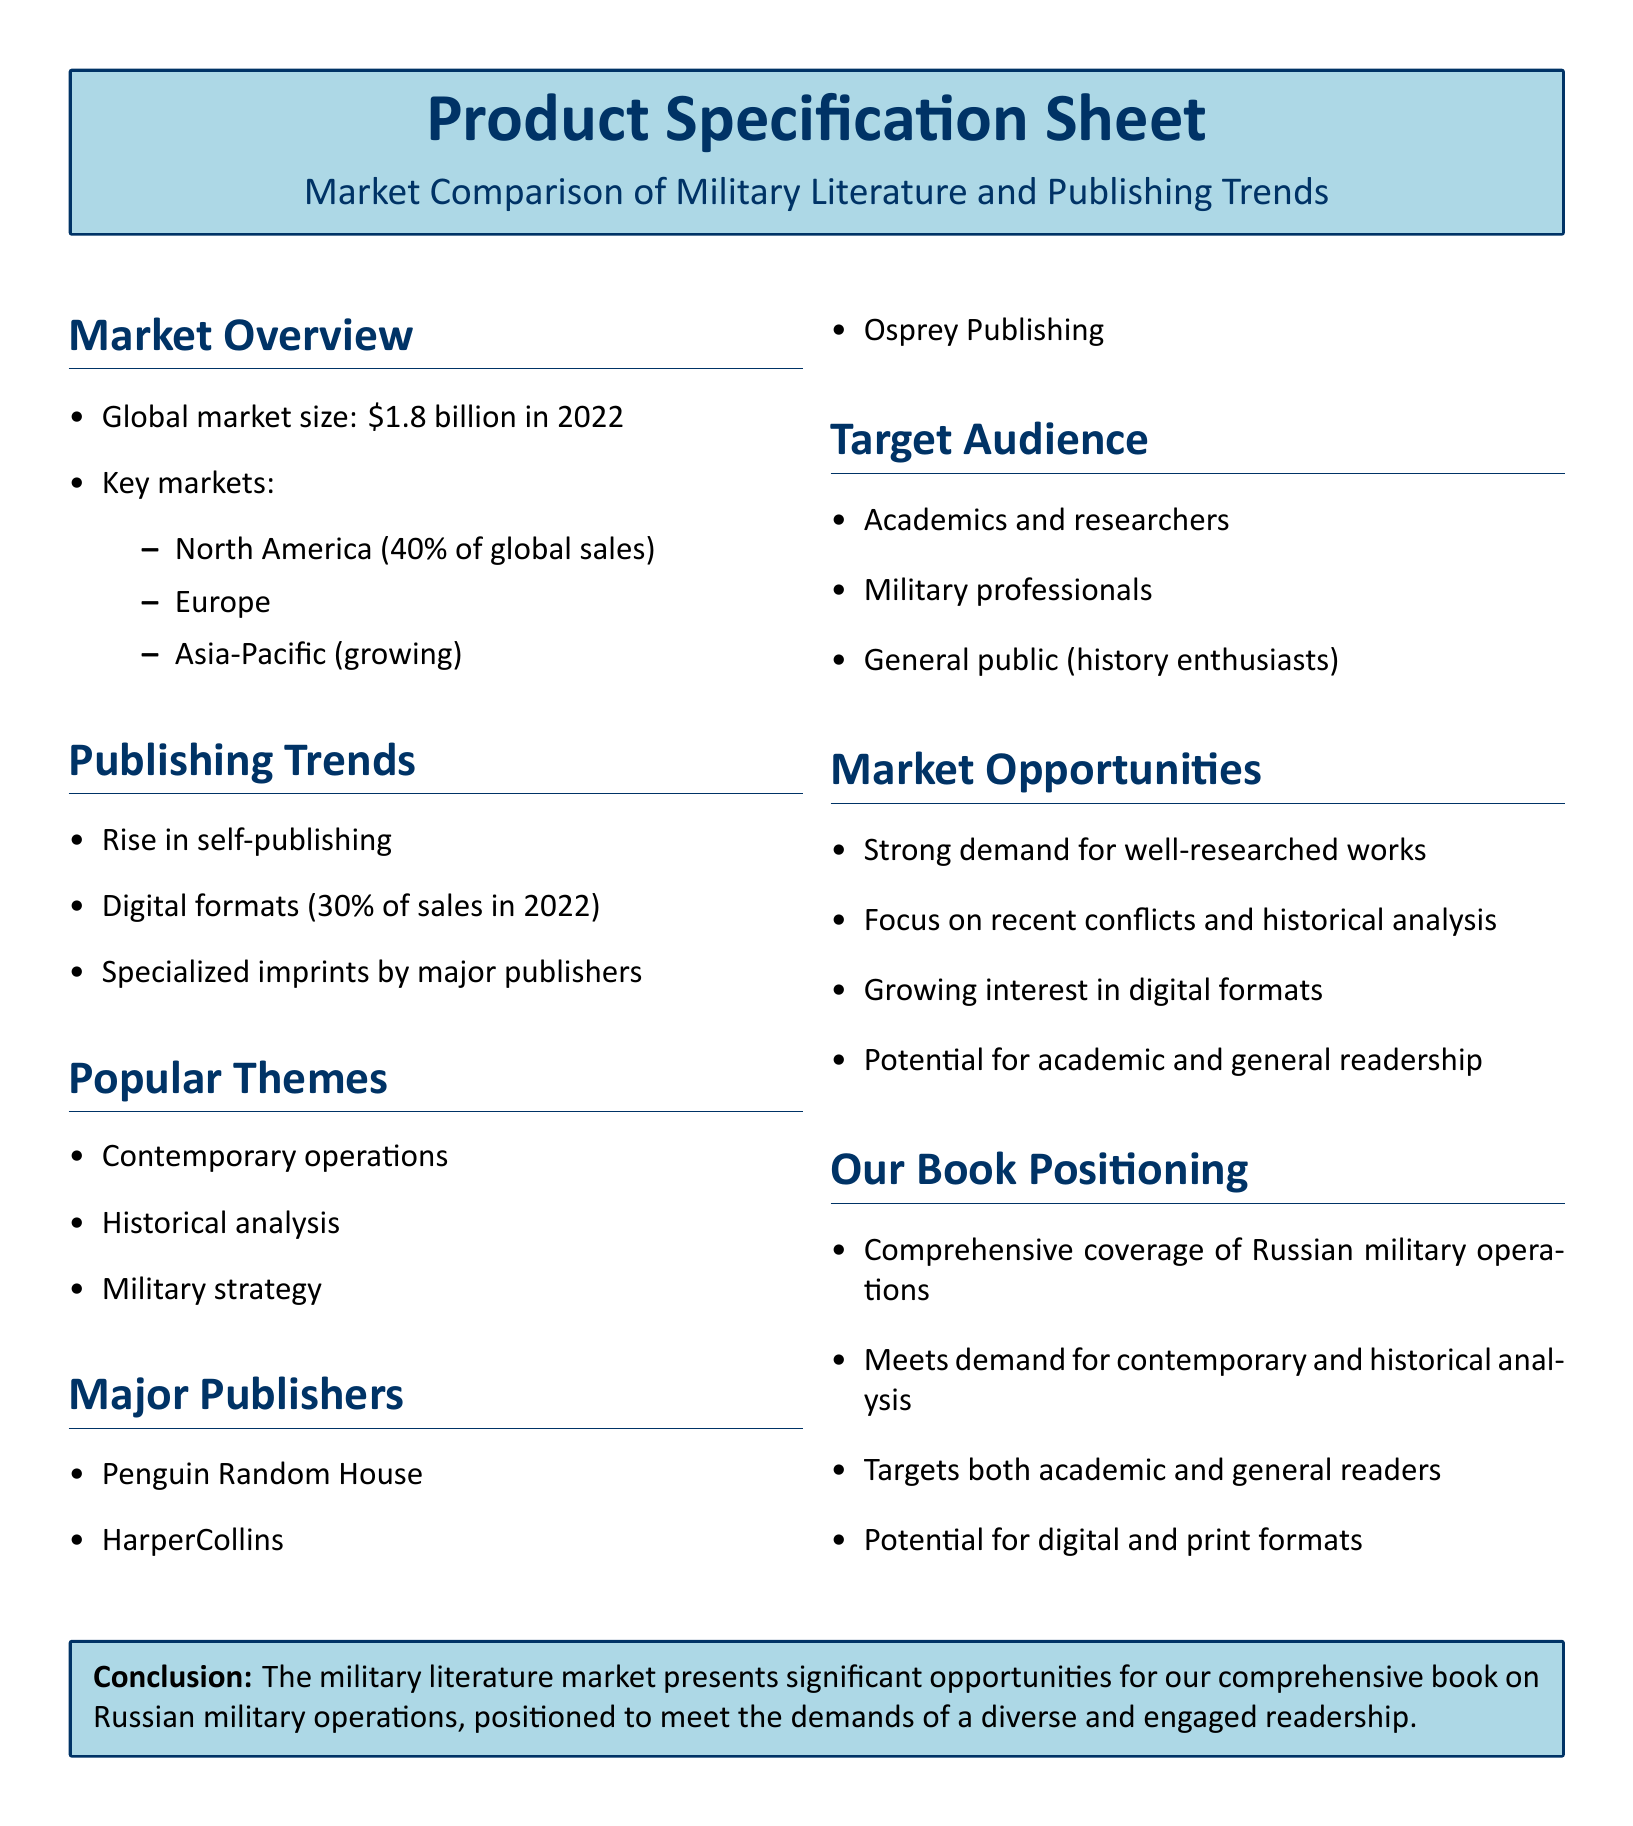What is the global market size for military literature in 2022? The document provides a specific figure, which is $1.8 billion in 2022.
Answer: $1.8 billion Which region accounts for 40% of global sales? The document specifies that North America accounts for this percentage of global sales.
Answer: North America What percentage of sales were digital formats in 2022? This information shows the trend towards digital publishing, with 30% of sales being digital formats.
Answer: 30% Name a major publisher mentioned in the document. The document lists several publishers, one of which is Penguin Random House.
Answer: Penguin Random House What is a popular theme in military literature? The document outlines several themes, including contemporary operations.
Answer: Contemporary operations What type of readers is our book targeting? The document outlines several target audiences, including academics and researchers.
Answer: Academics and researchers What is a key market opportunity identified in the document? The document points out a strong demand for well-researched works as a key market opportunity.
Answer: Strong demand for well-researched works Which aspect does our book meet in terms of demand? The document highlights that our book meets the demand for contemporary and historical analysis.
Answer: Contemporary and historical analysis What format potential is mentioned for the book? The document indicates that there is potential for both digital and print formats for the book.
Answer: Digital and print formats 